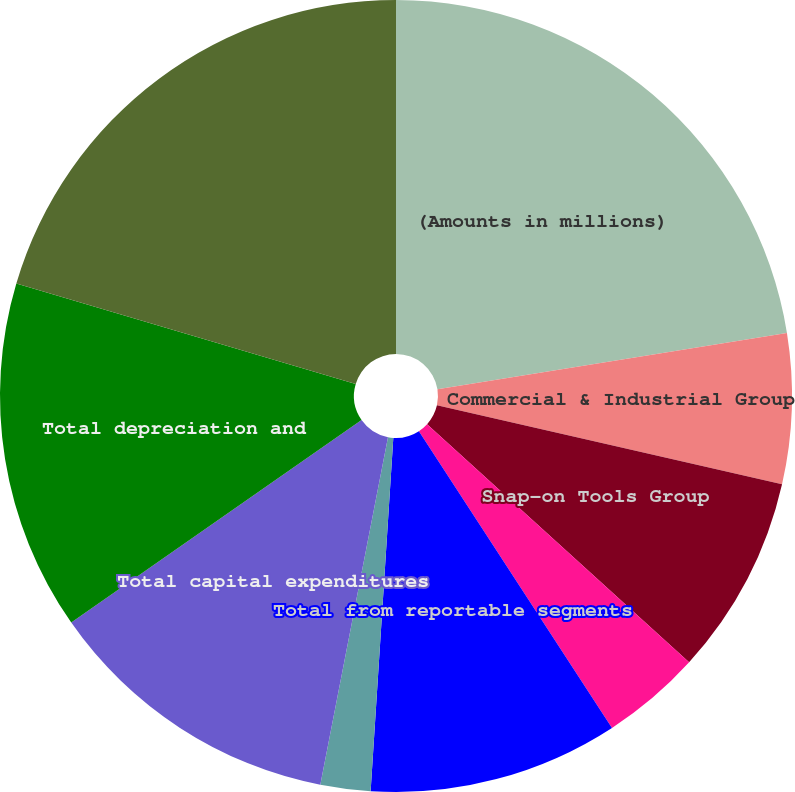Convert chart. <chart><loc_0><loc_0><loc_500><loc_500><pie_chart><fcel>(Amounts in millions)<fcel>Commercial & Industrial Group<fcel>Snap-on Tools Group<fcel>Repair Systems & Information<fcel>Financial Services<fcel>Total from reportable segments<fcel>Corporate<fcel>Total capital expenditures<fcel>Total depreciation and<fcel>Revenues by geographic region<nl><fcel>22.45%<fcel>6.12%<fcel>8.16%<fcel>4.08%<fcel>0.0%<fcel>10.2%<fcel>2.04%<fcel>12.24%<fcel>14.28%<fcel>20.41%<nl></chart> 